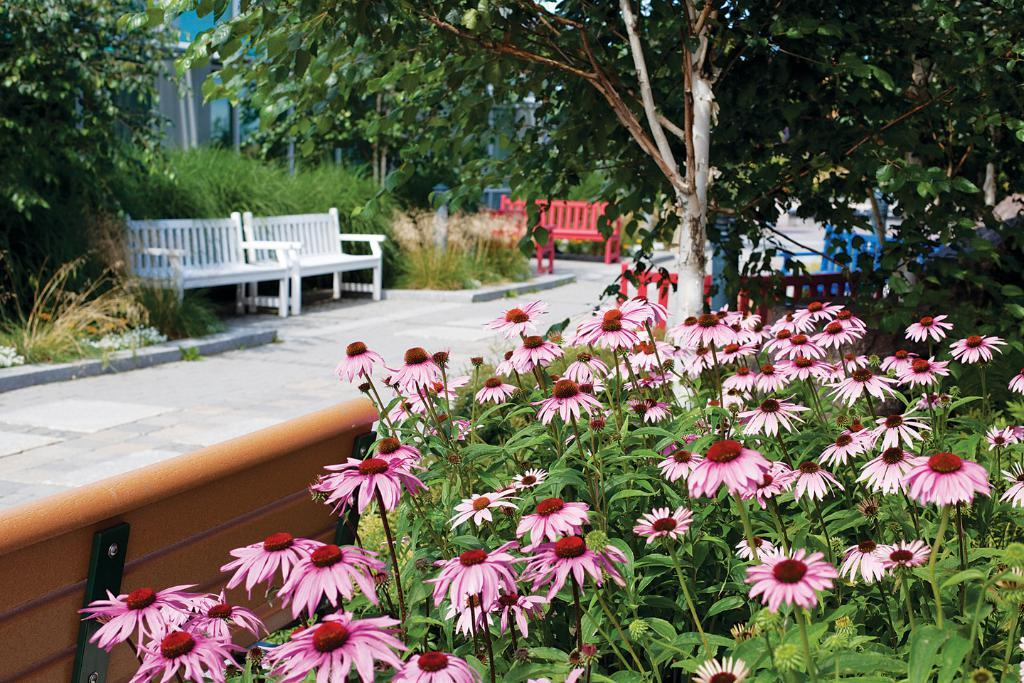What type of vegetation is present in the image? There are flowers with plants in the image. What type of seating can be seen in the background of the image? There are benches in the background of the image. What other types of vegetation are visible in the background of the image? There are shrubs and trees in the background of the image. What type of plastic material is used to create the square in the image? There is no plastic or square present in the image. 